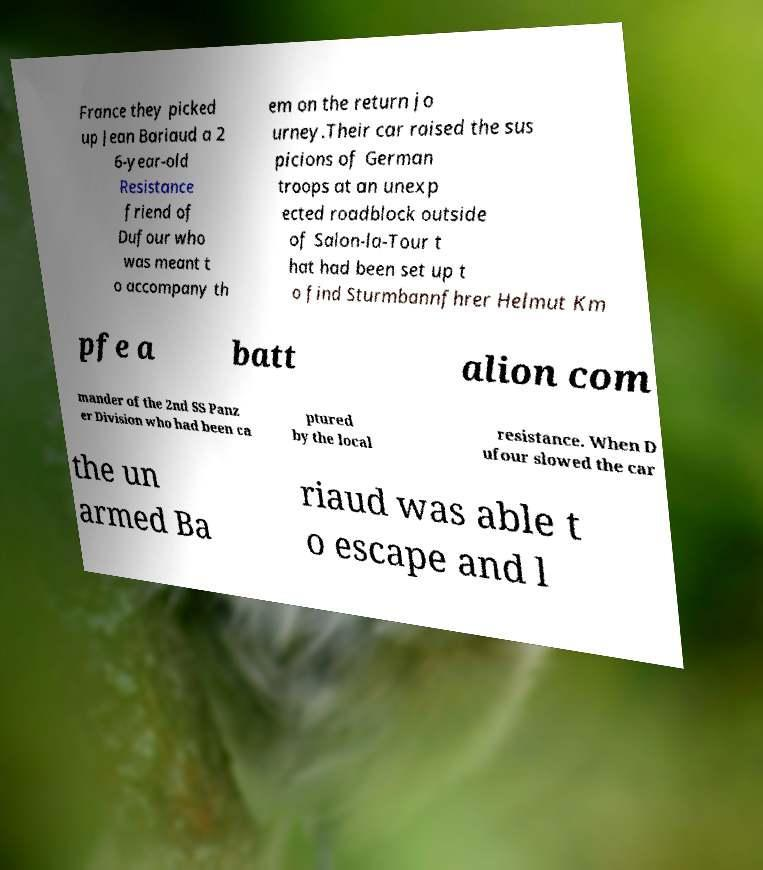Could you assist in decoding the text presented in this image and type it out clearly? France they picked up Jean Bariaud a 2 6-year-old Resistance friend of Dufour who was meant t o accompany th em on the return jo urney.Their car raised the sus picions of German troops at an unexp ected roadblock outside of Salon-la-Tour t hat had been set up t o find Sturmbannfhrer Helmut Km pfe a batt alion com mander of the 2nd SS Panz er Division who had been ca ptured by the local resistance. When D ufour slowed the car the un armed Ba riaud was able t o escape and l 